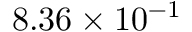Convert formula to latex. <formula><loc_0><loc_0><loc_500><loc_500>8 . 3 6 \times 1 0 ^ { - 1 }</formula> 